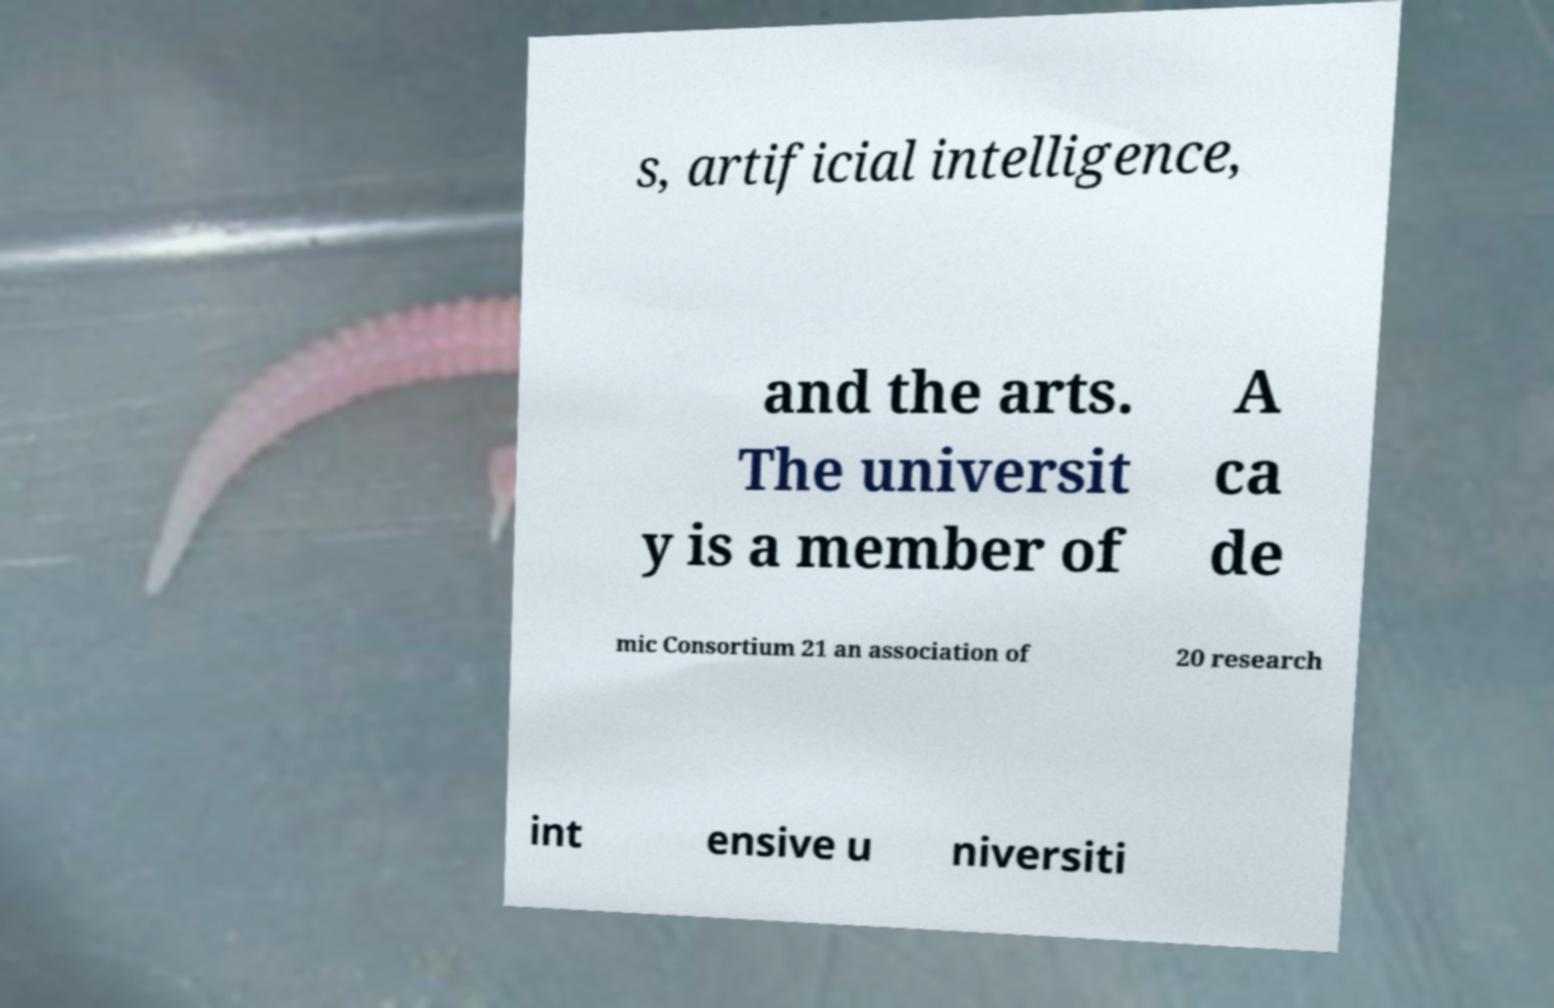For documentation purposes, I need the text within this image transcribed. Could you provide that? s, artificial intelligence, and the arts. The universit y is a member of A ca de mic Consortium 21 an association of 20 research int ensive u niversiti 